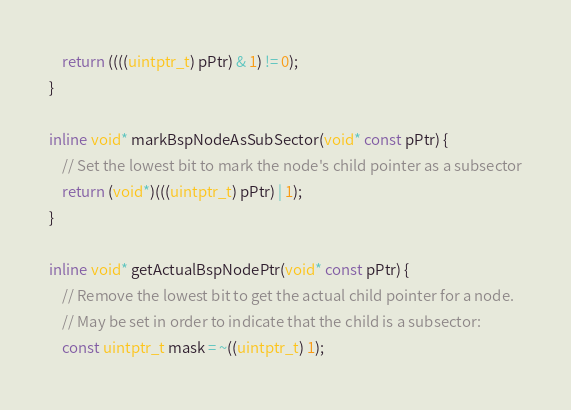<code> <loc_0><loc_0><loc_500><loc_500><_C_>    return ((((uintptr_t) pPtr) & 1) != 0);
}

inline void* markBspNodeAsSubSector(void* const pPtr) {
    // Set the lowest bit to mark the node's child pointer as a subsector
    return (void*)(((uintptr_t) pPtr) | 1);
}

inline void* getActualBspNodePtr(void* const pPtr) {
    // Remove the lowest bit to get the actual child pointer for a node.
    // May be set in order to indicate that the child is a subsector:
    const uintptr_t mask = ~((uintptr_t) 1);</code> 